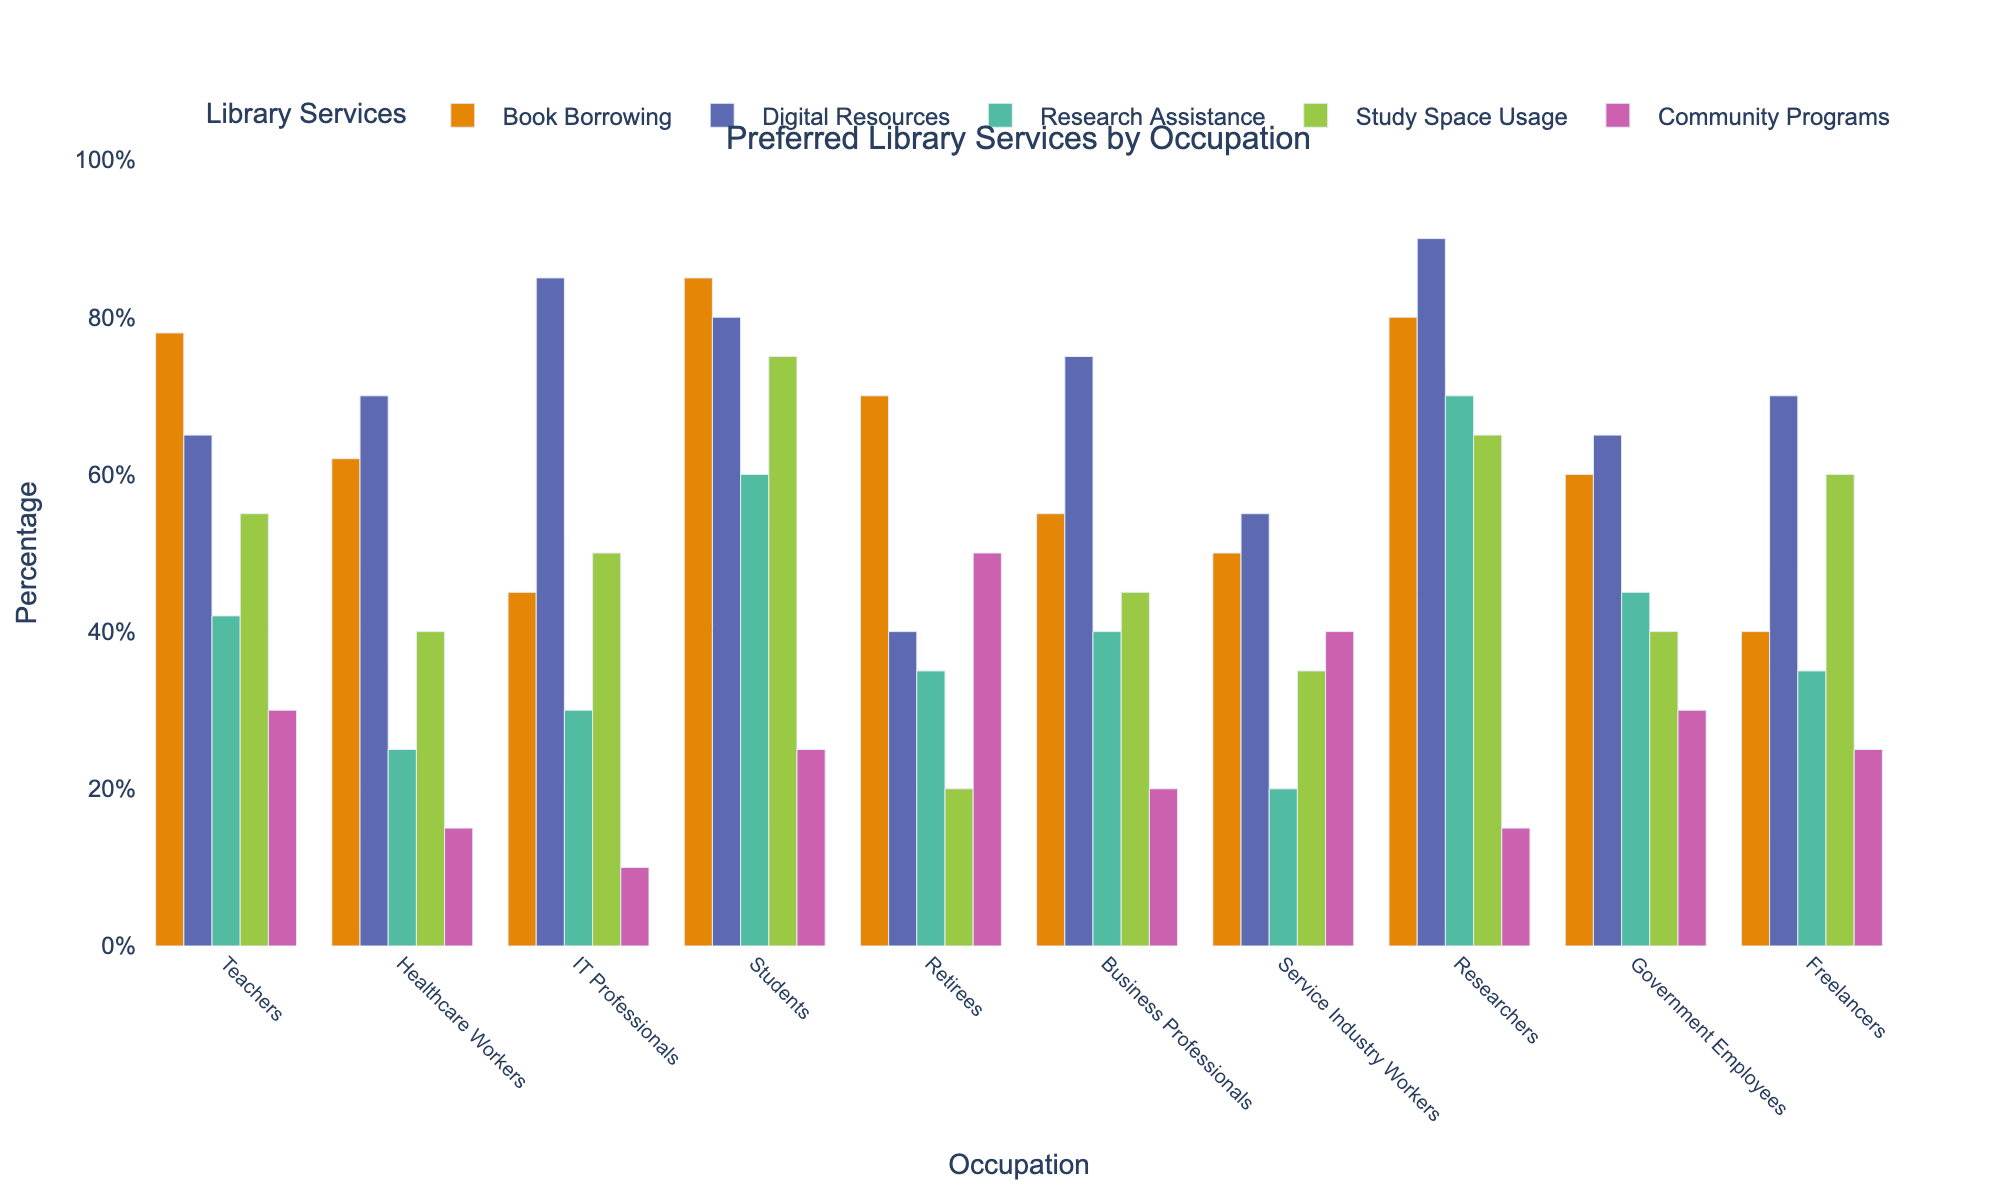Which occupational category has the highest preference for book borrowing? Aligning the bar heights for Book Borrowing shows Students have the tallest bar, indicating the highest preference for book borrowing.
Answer: Students Among IT Professionals and Business Professionals, who has a higher preference for digital resources? Comparing the bar heights for Digital Resources between IT Professionals and Business Professionals, IT Professionals have a taller bar.
Answer: IT Professionals What is the total percentage of preference for community programs among the Teachers, Healthcare Workers, and Service Industry Workers? Adding up the Community Programs percentages for Teachers (30), Healthcare Workers (15), and Service Industry Workers (40) gives 30 + 15 + 40 = 85.
Answer: 85% Which occupational category shows the least interest in study space usage? Comparing the bar heights for Study Space Usage across all categories, Retirees have the shortest bar.
Answer: Retirees What is the difference in preference for research assistance between Students and Healthcare Workers? Subtracting the Research Assistance percentage of Healthcare Workers (25) from that of Students (60), we get 60 - 25 = 35.
Answer: 35% How does the preference for digital resources among Teachers compare to Healthcare Workers? Examining the bar heights for Digital Resources, Teachers have a shorter bar at 65 compared to Healthcare Workers' bar at 70.
Answer: Healthcare Workers prefer digital resources more Which occupational category has the second-highest preference for community programs? Identifying the second tallest bar for Community Programs places Retirees (50) just after Service Industry Workers (40).
Answer: Retirees Which service is most preferred by Researchers? By observing Researchers' section, the highest bar belongs to Digital Resources (90).
Answer: Digital Resources What is the average percentage preference for research assistance among Teachers, Business Professionals, and Government Employees? Summing and averaging their preferences: (42 + 40 + 45) / 3 = 127 / 3 ≈ 42.33.
Answer: 42.33% Which occupational category has a preference for book borrowing closest to 60%? Checking bar heights closest to 60% for Book Borrowing, Government Employees have a bar at 60.
Answer: Government Employees 